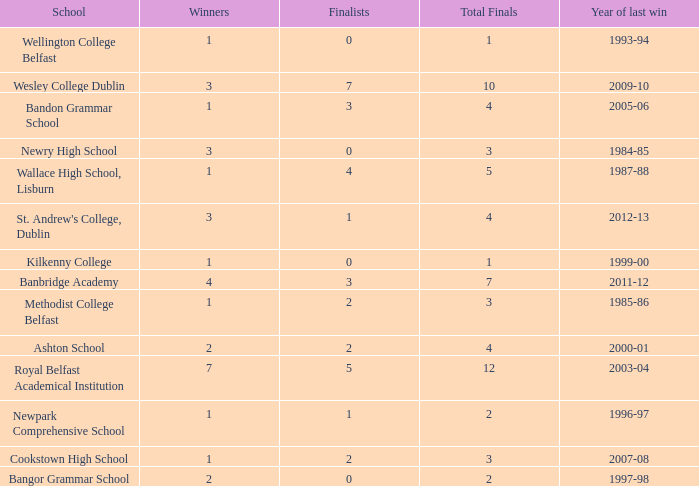In what year was the total finals at 10? 2009-10. 